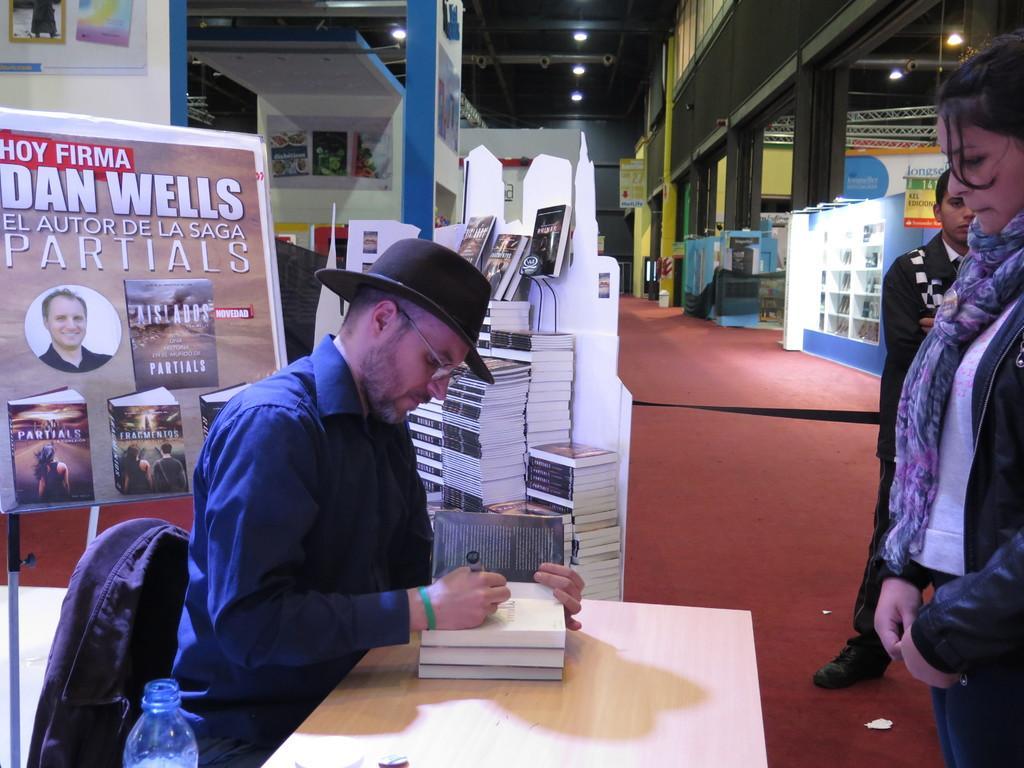Please provide a concise description of this image. In this picture we can see a man who is sitting on the chair. This is the table. On the table there are some books. He wear a cap and he has spectacles. Here we can see two persons standing on the floor. These are some books. On the background there is a hoarding. And these are the lights. 